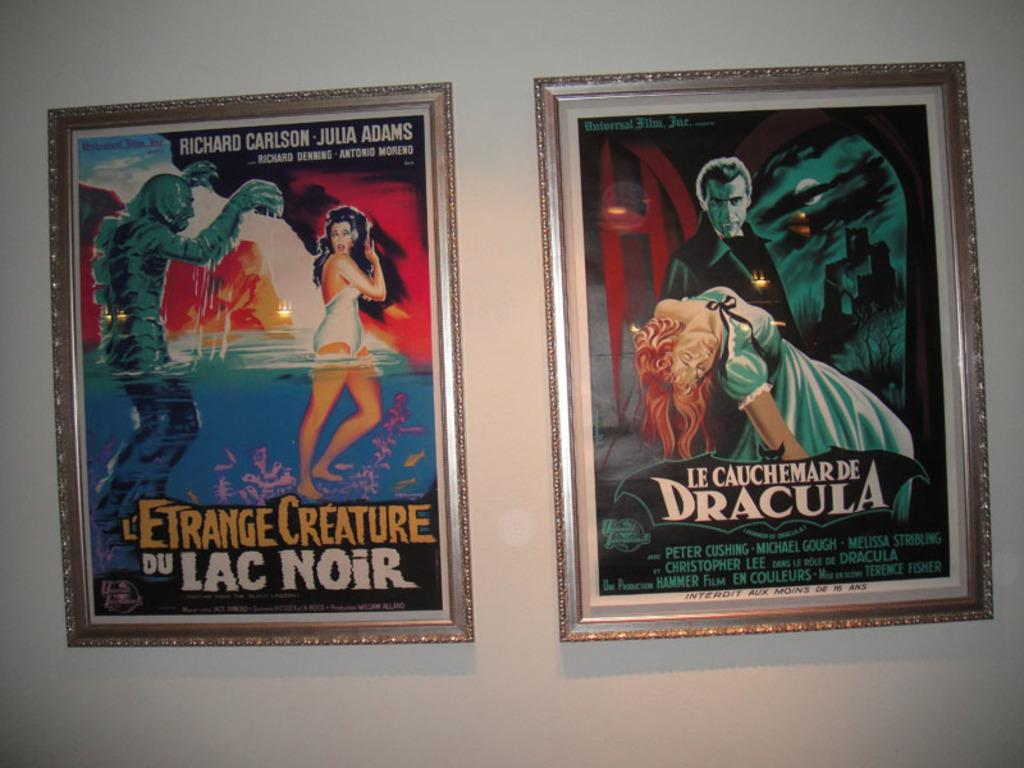Provide a one-sentence caption for the provided image. Two posters for Creature from the Black Lagoon and Dracula. 